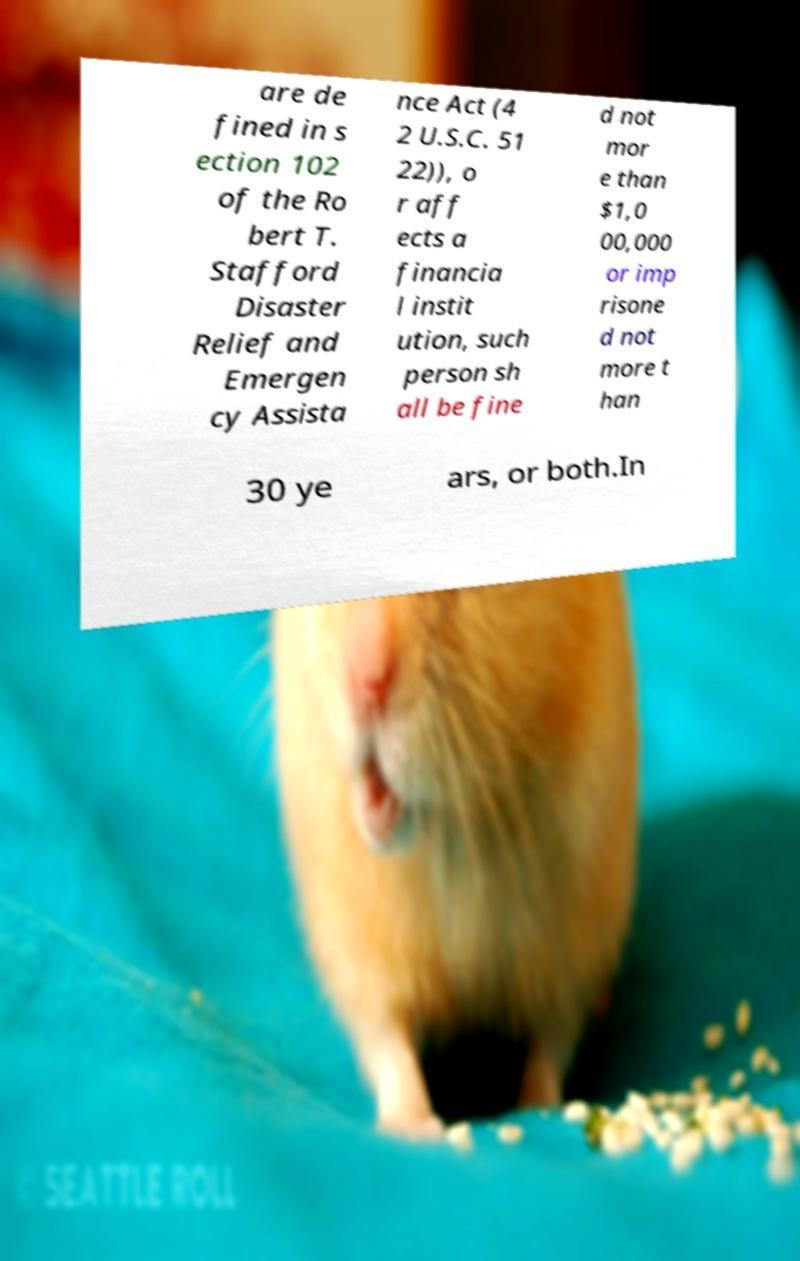Could you assist in decoding the text presented in this image and type it out clearly? are de fined in s ection 102 of the Ro bert T. Stafford Disaster Relief and Emergen cy Assista nce Act (4 2 U.S.C. 51 22)), o r aff ects a financia l instit ution, such person sh all be fine d not mor e than $1,0 00,000 or imp risone d not more t han 30 ye ars, or both.In 